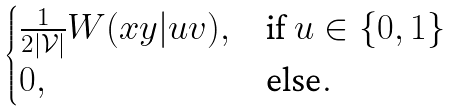<formula> <loc_0><loc_0><loc_500><loc_500>\begin{cases} \frac { 1 } { 2 | \mathcal { V } | } W ( x y | u v ) , & \text {if } u \in \{ 0 , 1 \} \\ 0 , & \text {else} . \end{cases}</formula> 